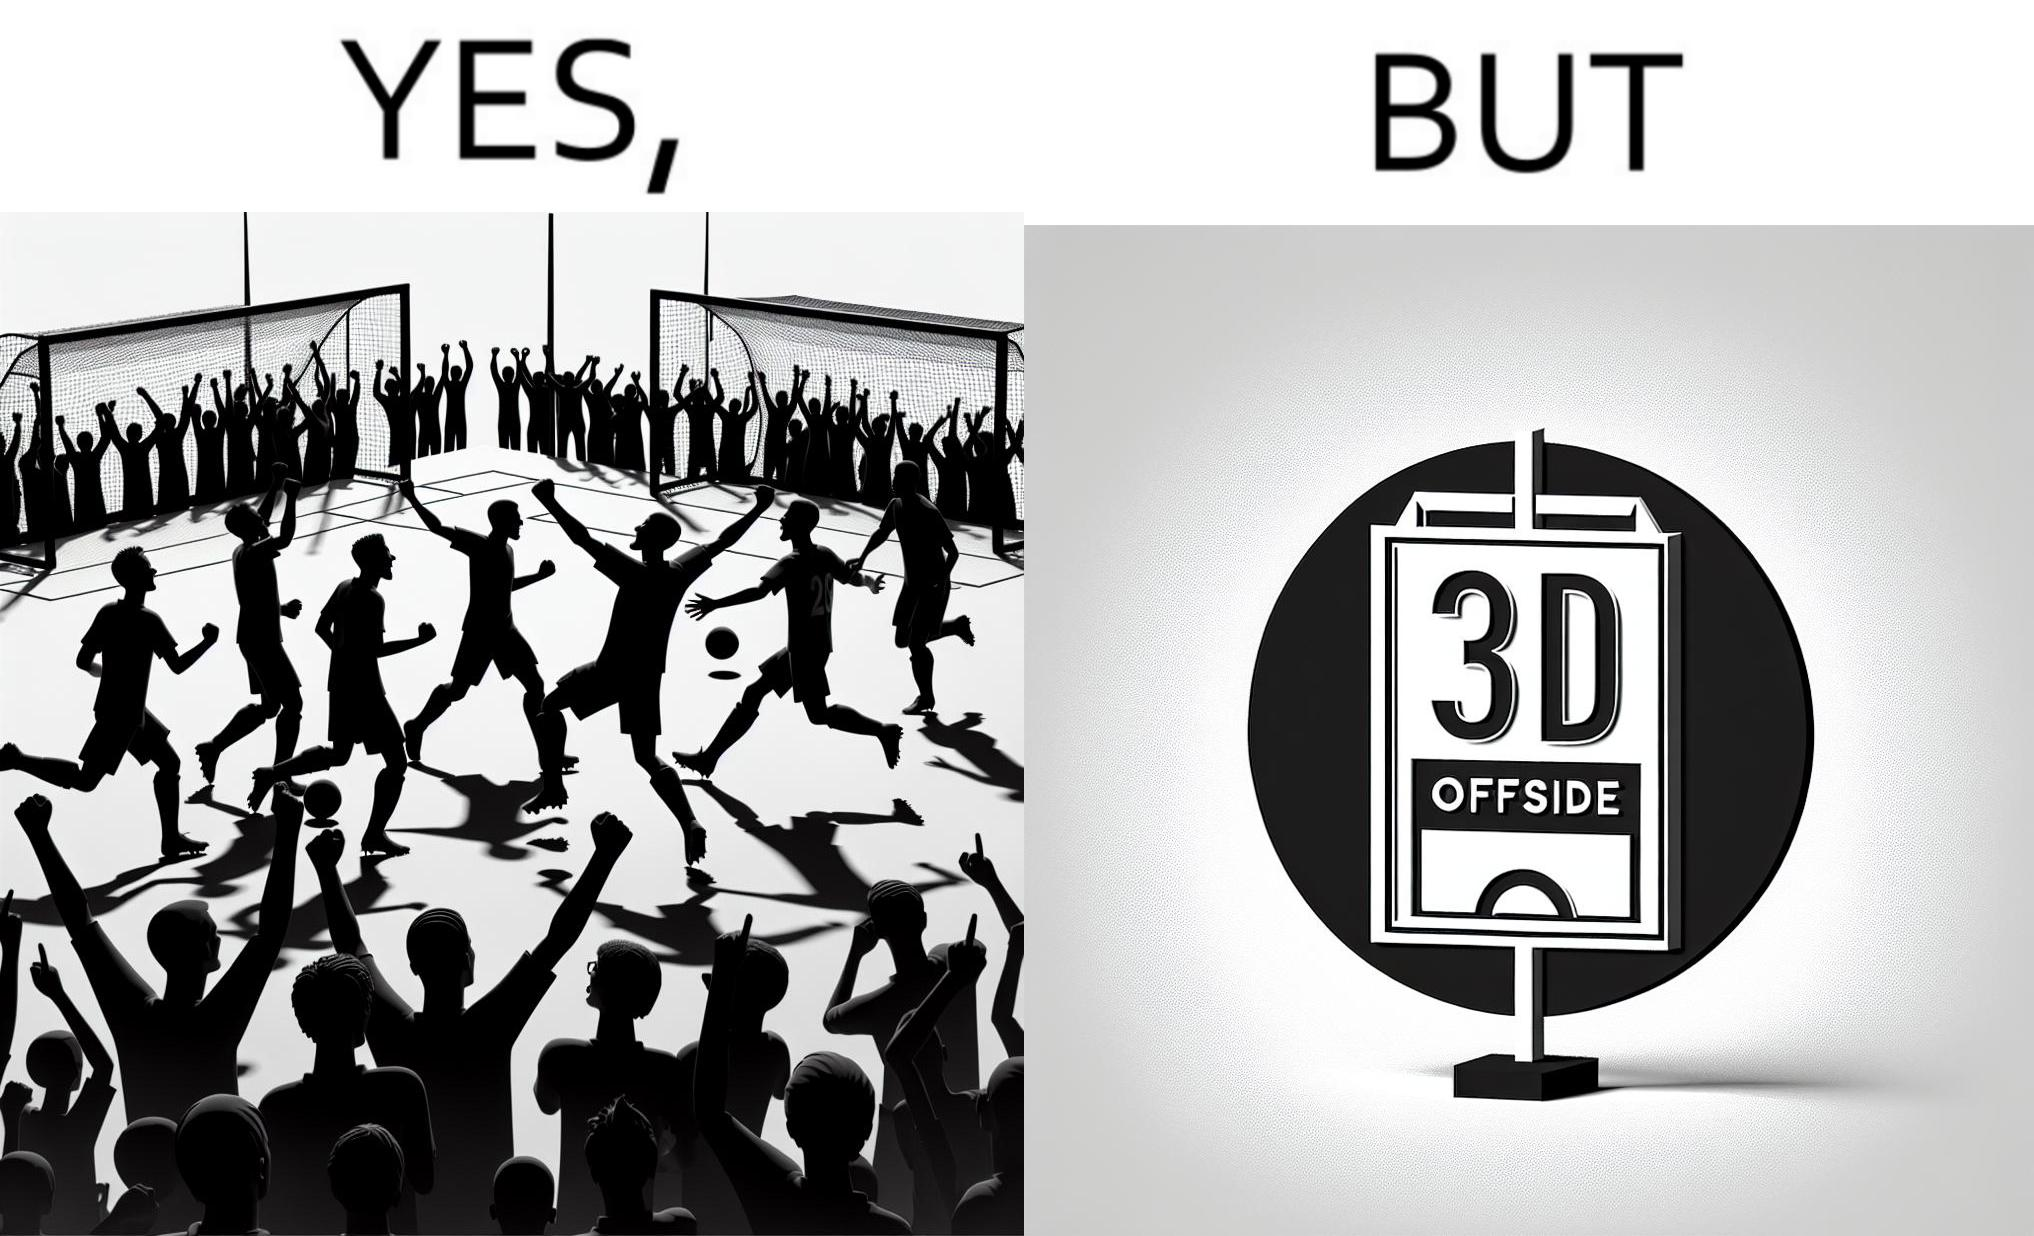Does this image contain satire or humor? Yes, this image is satirical. 